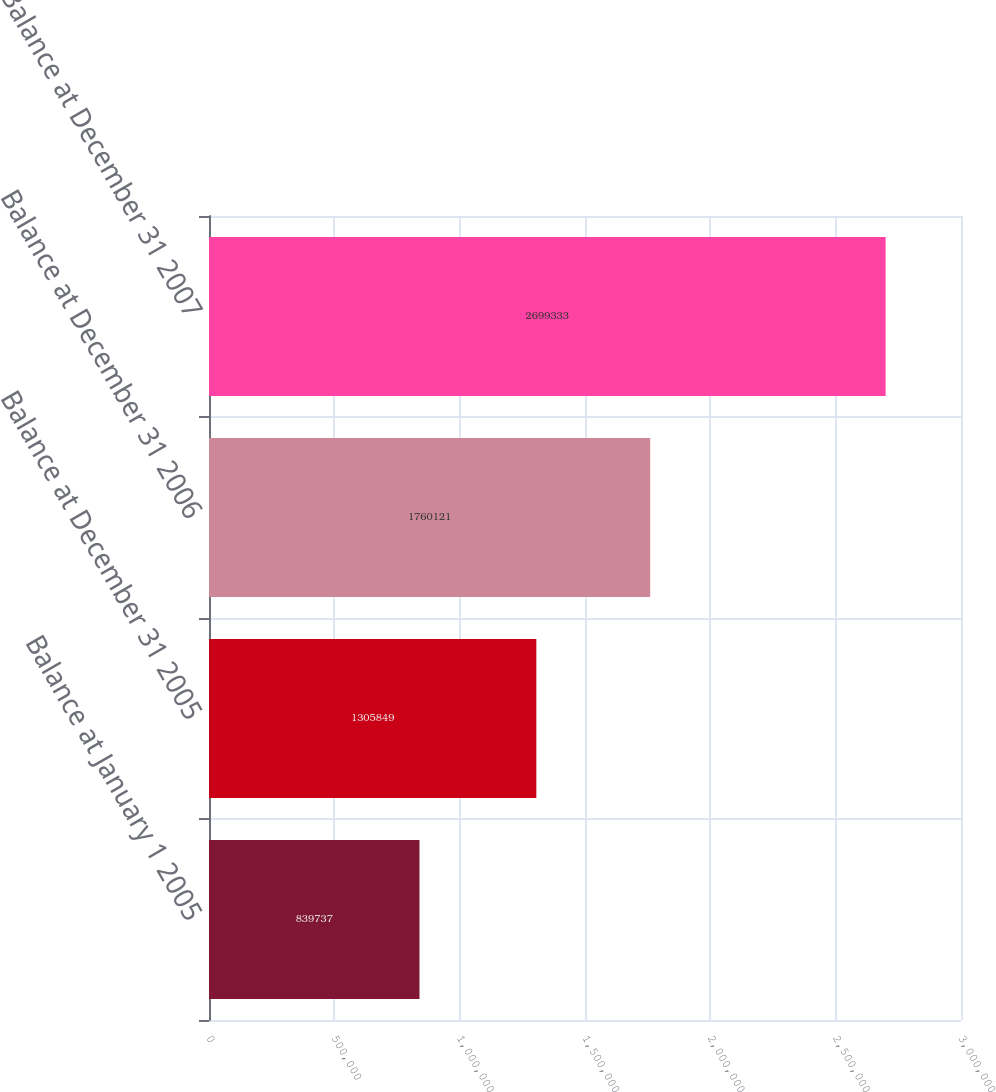Convert chart. <chart><loc_0><loc_0><loc_500><loc_500><bar_chart><fcel>Balance at January 1 2005<fcel>Balance at December 31 2005<fcel>Balance at December 31 2006<fcel>Balance at December 31 2007<nl><fcel>839737<fcel>1.30585e+06<fcel>1.76012e+06<fcel>2.69933e+06<nl></chart> 